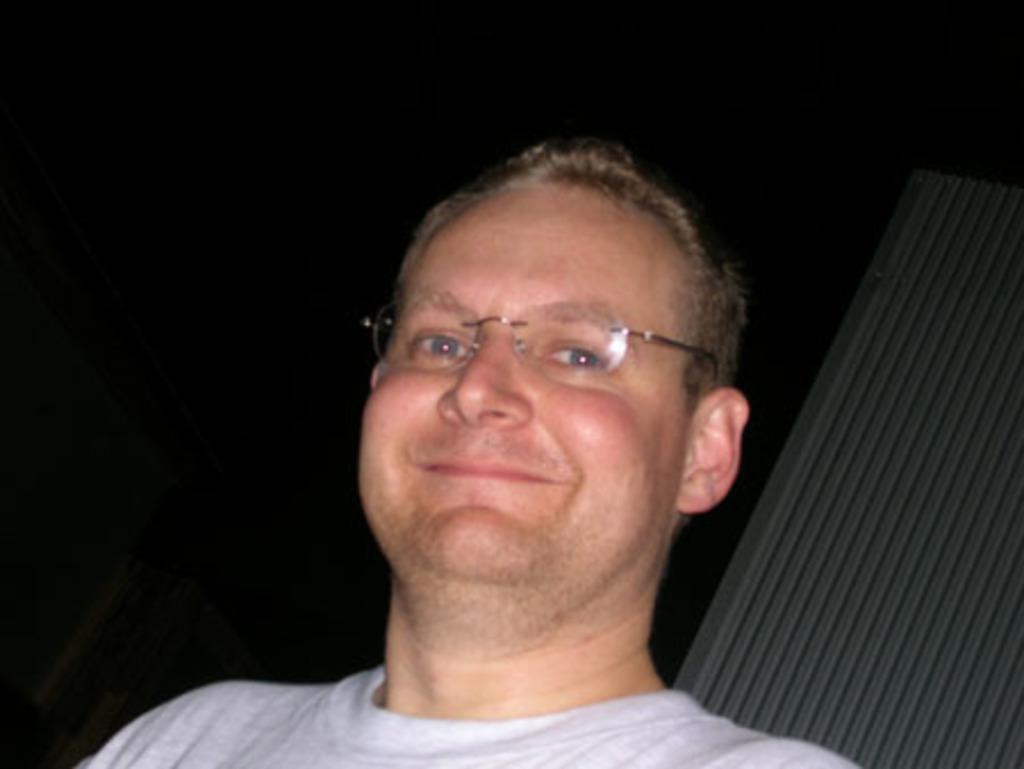Could you give a brief overview of what you see in this image? In the picture there is a man,he is posing for the photo and he is wearing spectacles. The background of the man is dark. 